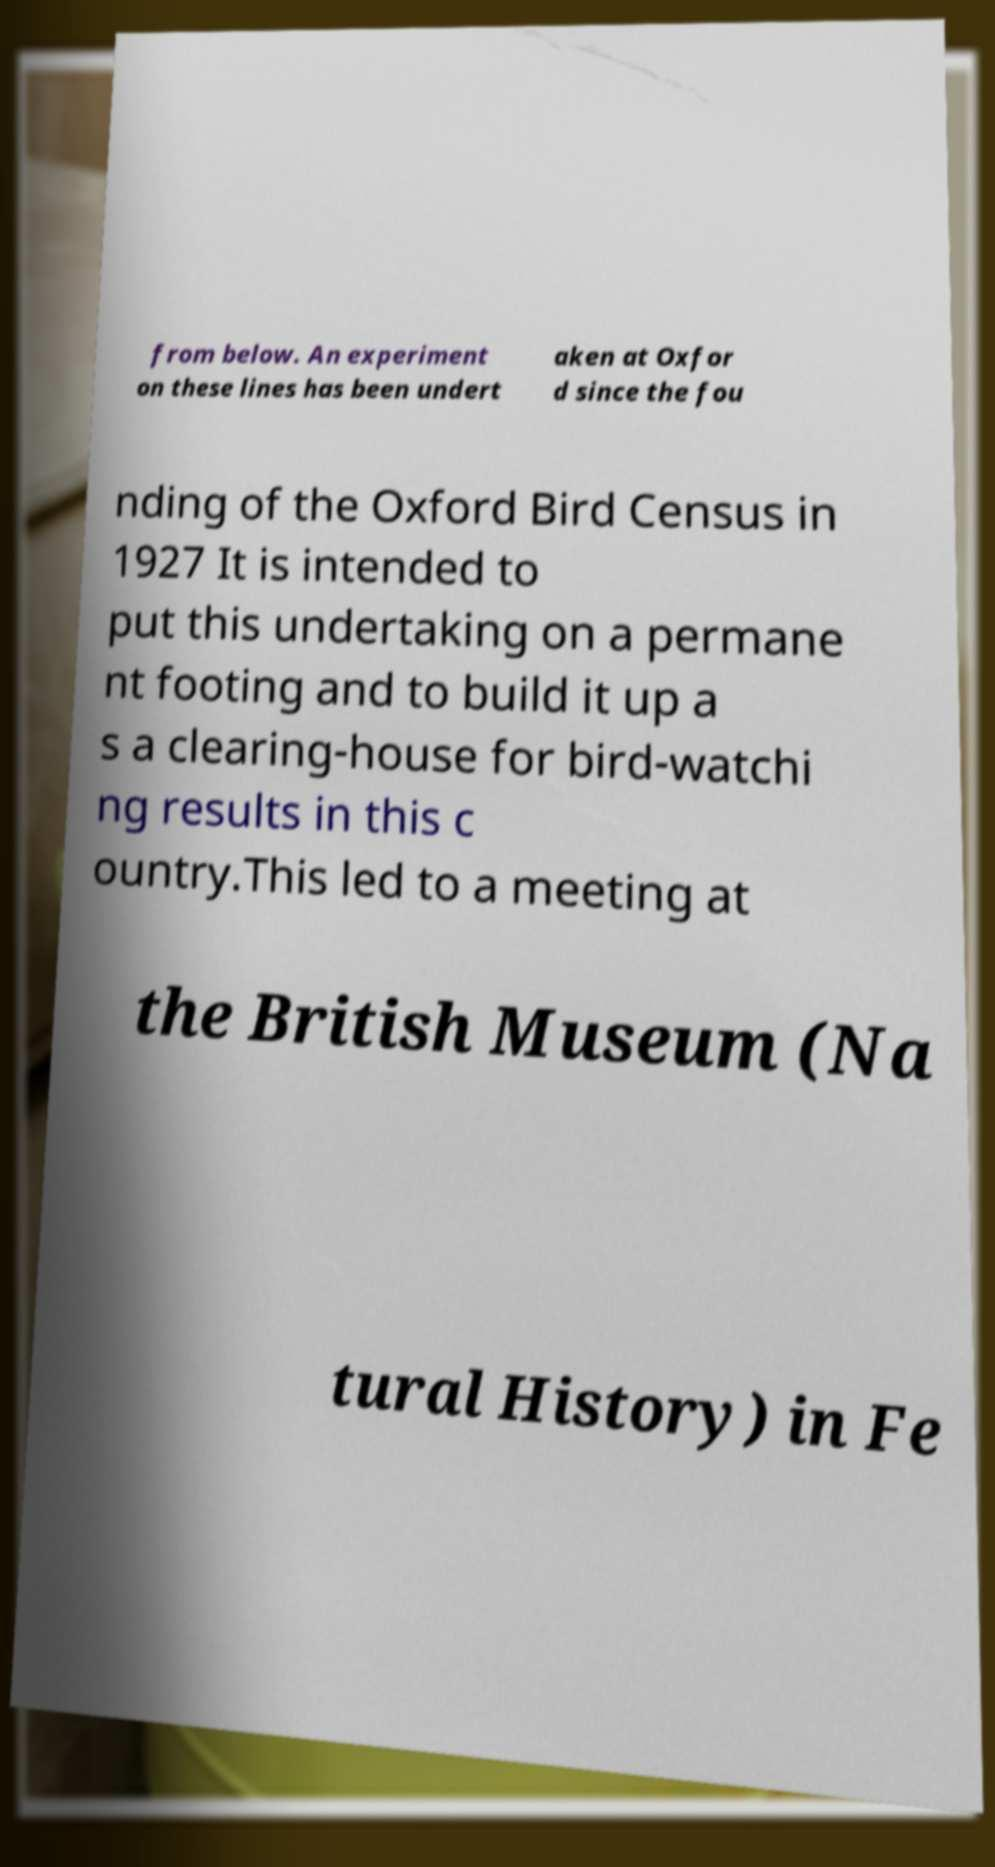Could you extract and type out the text from this image? from below. An experiment on these lines has been undert aken at Oxfor d since the fou nding of the Oxford Bird Census in 1927 It is intended to put this undertaking on a permane nt footing and to build it up a s a clearing-house for bird-watchi ng results in this c ountry.This led to a meeting at the British Museum (Na tural History) in Fe 